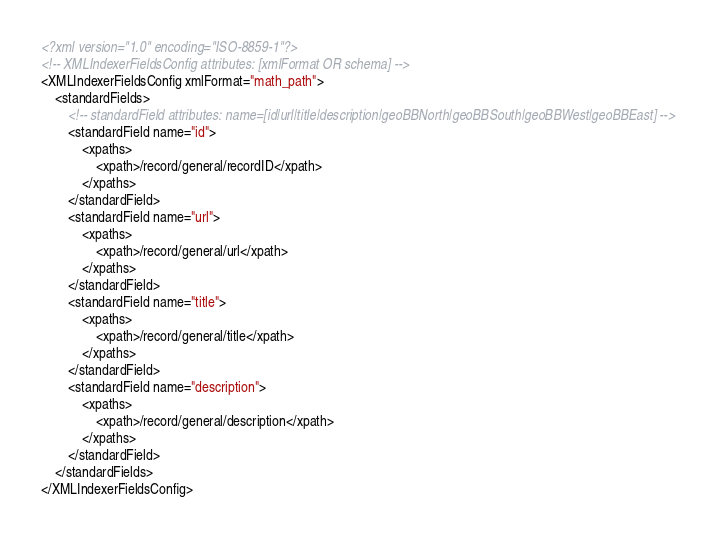<code> <loc_0><loc_0><loc_500><loc_500><_XML_><?xml version="1.0" encoding="ISO-8859-1"?>
<!-- XMLIndexerFieldsConfig attributes: [xmlFormat OR schema] -->
<XMLIndexerFieldsConfig xmlFormat="math_path">
	<standardFields>
		<!-- standardField attributes: name=[id|url|title|description|geoBBNorth|geoBBSouth|geoBBWest|geoBBEast] -->
		<standardField name="id">
			<xpaths>
				<xpath>/record/general/recordID</xpath>
			</xpaths>		
		</standardField>	
		<standardField name="url">
			<xpaths>
				<xpath>/record/general/url</xpath>
			</xpaths>		
		</standardField>
		<standardField name="title">
			<xpaths>
				<xpath>/record/general/title</xpath>
			</xpaths>		
		</standardField>
		<standardField name="description">
			<xpaths>
				<xpath>/record/general/description</xpath>
			</xpaths>		
		</standardField>		
	</standardFields>		
</XMLIndexerFieldsConfig>
</code> 